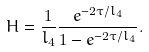Convert formula to latex. <formula><loc_0><loc_0><loc_500><loc_500>H = \frac { 1 } { l _ { 4 } } \frac { e ^ { - 2 \tau / l _ { 4 } } } { 1 - e ^ { - 2 \tau / l _ { 4 } } } .</formula> 